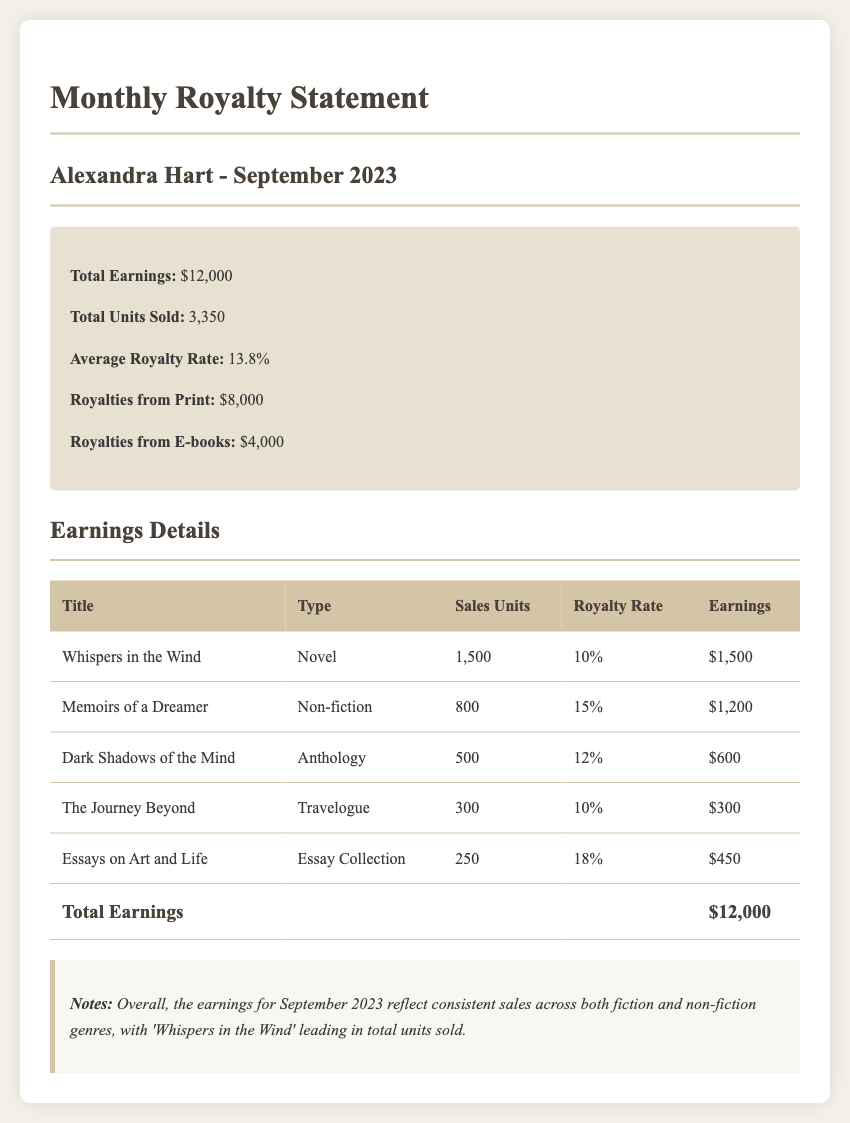What is the total earnings for September 2023? The total earnings is stated in the summary section of the document.
Answer: $12,000 How many units of "Whispers in the Wind" were sold? The document specifies the sales units for each title in the earnings details table.
Answer: 1,500 What is the royalty rate for "Essays on Art and Life"? The royalty rate is listed in the earnings details table for each title.
Answer: 18% Which literary work generated the highest earnings? By comparing the earnings from the earnings details table, the title with the highest earnings can be identified.
Answer: Whispers in the Wind What is the total number of units sold across all works? The total units sold is calculated by summing the sales units for each title in the earnings details table.
Answer: 3,350 What type of work is "Dark Shadows of the Mind"? The type of work is specified in the earnings details table next to each title.
Answer: Anthology What was the royalties from E-books? The royalties from E-books are summarized in the summary section of the document.
Answer: $4,000 What notes are provided regarding the overall earnings for September 2023? The notes section contains a summary of insights and observations regarding the earnings for the month.
Answer: Consistent sales across both fiction and non-fiction genres 